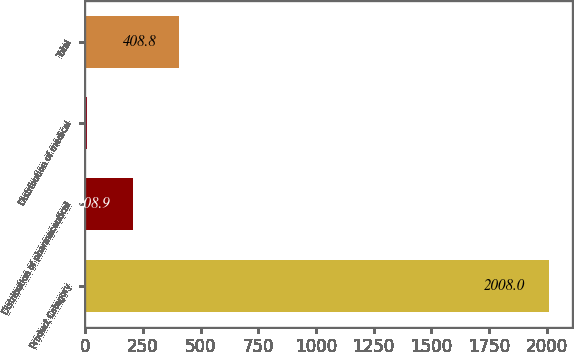Convert chart. <chart><loc_0><loc_0><loc_500><loc_500><bar_chart><fcel>Product Category<fcel>Distribution of pharmaceutical<fcel>Distribution of medical<fcel>Total<nl><fcel>2008<fcel>208.9<fcel>9<fcel>408.8<nl></chart> 